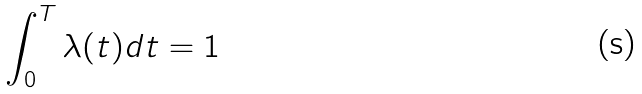Convert formula to latex. <formula><loc_0><loc_0><loc_500><loc_500>\int _ { 0 } ^ { T } \lambda ( t ) d t = 1</formula> 